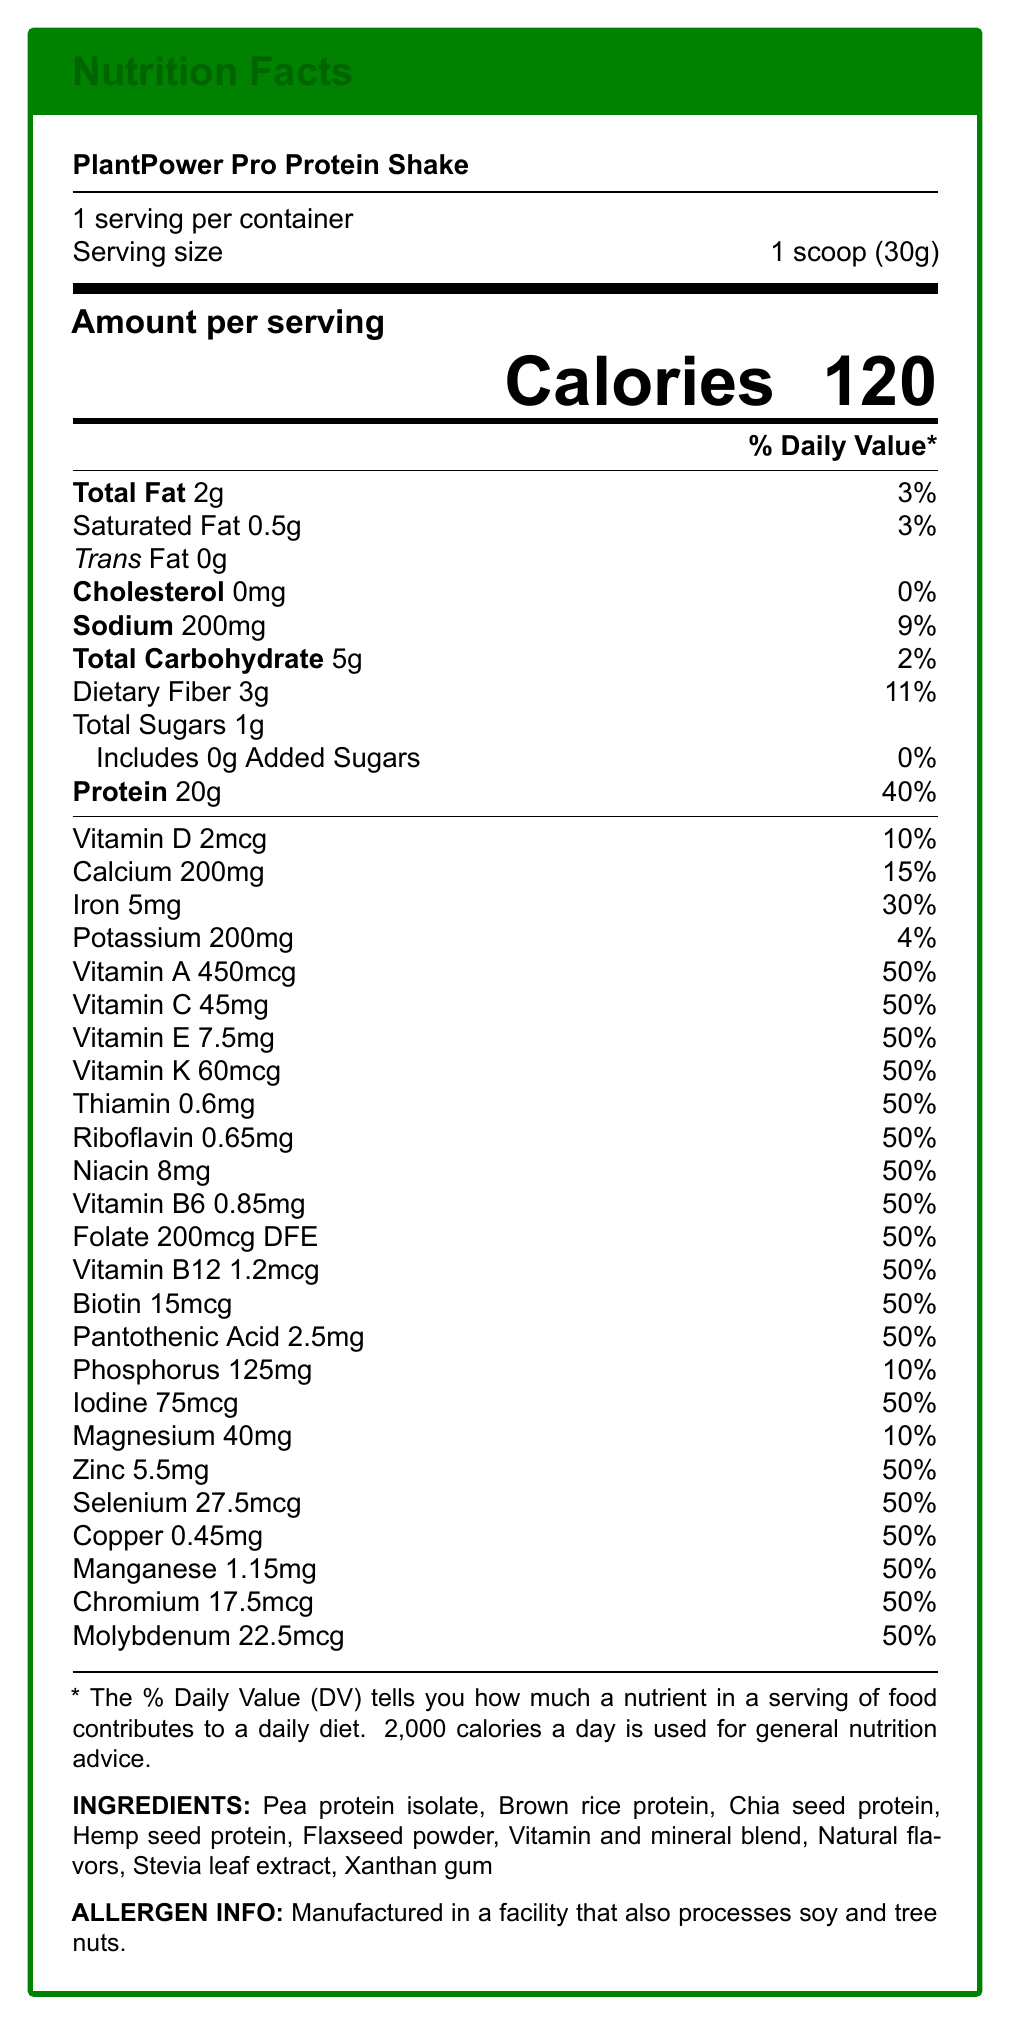What is the serving size for PlantPower Pro Protein Shake? The serving size is clearly stated as 1 scoop (30g) in the document.
Answer: 1 scoop (30g) How many servings are there per container of the protein shake? According to the document, there are 15 servings per container.
Answer: 15 How many calories are in one serving of the protein shake? The amount of calories per serving is listed as 120 in the document.
Answer: 120 What is the total fat content in one serving of the shake? The document indicates that the total fat content per serving is 2g.
Answer: 2g How much dietary fiber is present per serving, and what is its daily value percentage? The dietary fiber content per serving is 3g, which is 11% of the daily value.
Answer: 3g, 11% Which two minerals have a daily value percentage of 10%? A. Calcium and Potassium B. Vitamin D and Phosphorus C. Phosphorus and Magnesium D. Sodium and Iron Phosphorus and Magnesium both have a daily value percentage of 10%, as listed in the document.
Answer: C. Phosphorus and Magnesium What is the percentage of daily value for Vitamin C per serving? A. 15% B. 30% C. 50% D. 60% The document shows that Vitamin C has a daily value percentage of 50%.
Answer: C. 50% Does the product contain any cholesterol? The document lists the cholesterol content as 0mg, which means no cholesterol is present in the product.
Answer: No Describe the vitamin and mineral profile of the PlantPower Pro Protein Shake. The detailed nutritional information provided in the document shows high percentages for numerous vitamins and minerals, indicating a nutrient-rich product.
Answer: The PlantPower Pro Protein Shake has a comprehensive vitamin and mineral profile. It provides high percentages of daily recommended intakes for various vitamins and minerals, such as Vitamin A, C, D, E, K, B6, B12, Folate, Thiamin, Riboflavin, Niacin, Biotin, Pantothenic Acid, Iodine, Zinc, Selenium, Copper, Manganese, Chromium, and Molybdenum, each at around 50% of the daily value. Essential minerals like Calcium, Iron, Phosphorus, Potassium, and Magnesium are also included. What type of protein is used in the PlantPower Pro Protein Shake? The ingredients list mentions Pea protein isolate, Brown rice protein, Chia seed protein, and Hemp seed protein as the sources of protein.
Answer: Pea protein isolate, Brown rice protein, Chia seed protein, Hemp seed protein Is the PlantPower Pro Protein Shake suitable for individuals concerned about cardiovascular health? The product is beneficial for cardiovascular health due to its low fat and cholesterol content, as indicated in the medical context section of the document.
Answer: Yes How much calcium is in one serving of the protein shake? The document specifies that one serving contains 200mg of calcium.
Answer: 200mg What is the total amount of sodium in one serving, and what percentage does it meet of the daily value? The document states that one serving has 200mg of sodium, which is 9% of the daily value.
Answer: 200mg, 9% Can it be determined how much brown rice protein is in the product? The document lists brown rice protein as an ingredient but does not give the specific amount present in the product.
Answer: Cannot be determined 